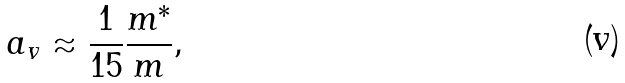Convert formula to latex. <formula><loc_0><loc_0><loc_500><loc_500>a _ { v } \approx \frac { 1 } { 1 5 } \frac { m ^ { * } } { m } ,</formula> 